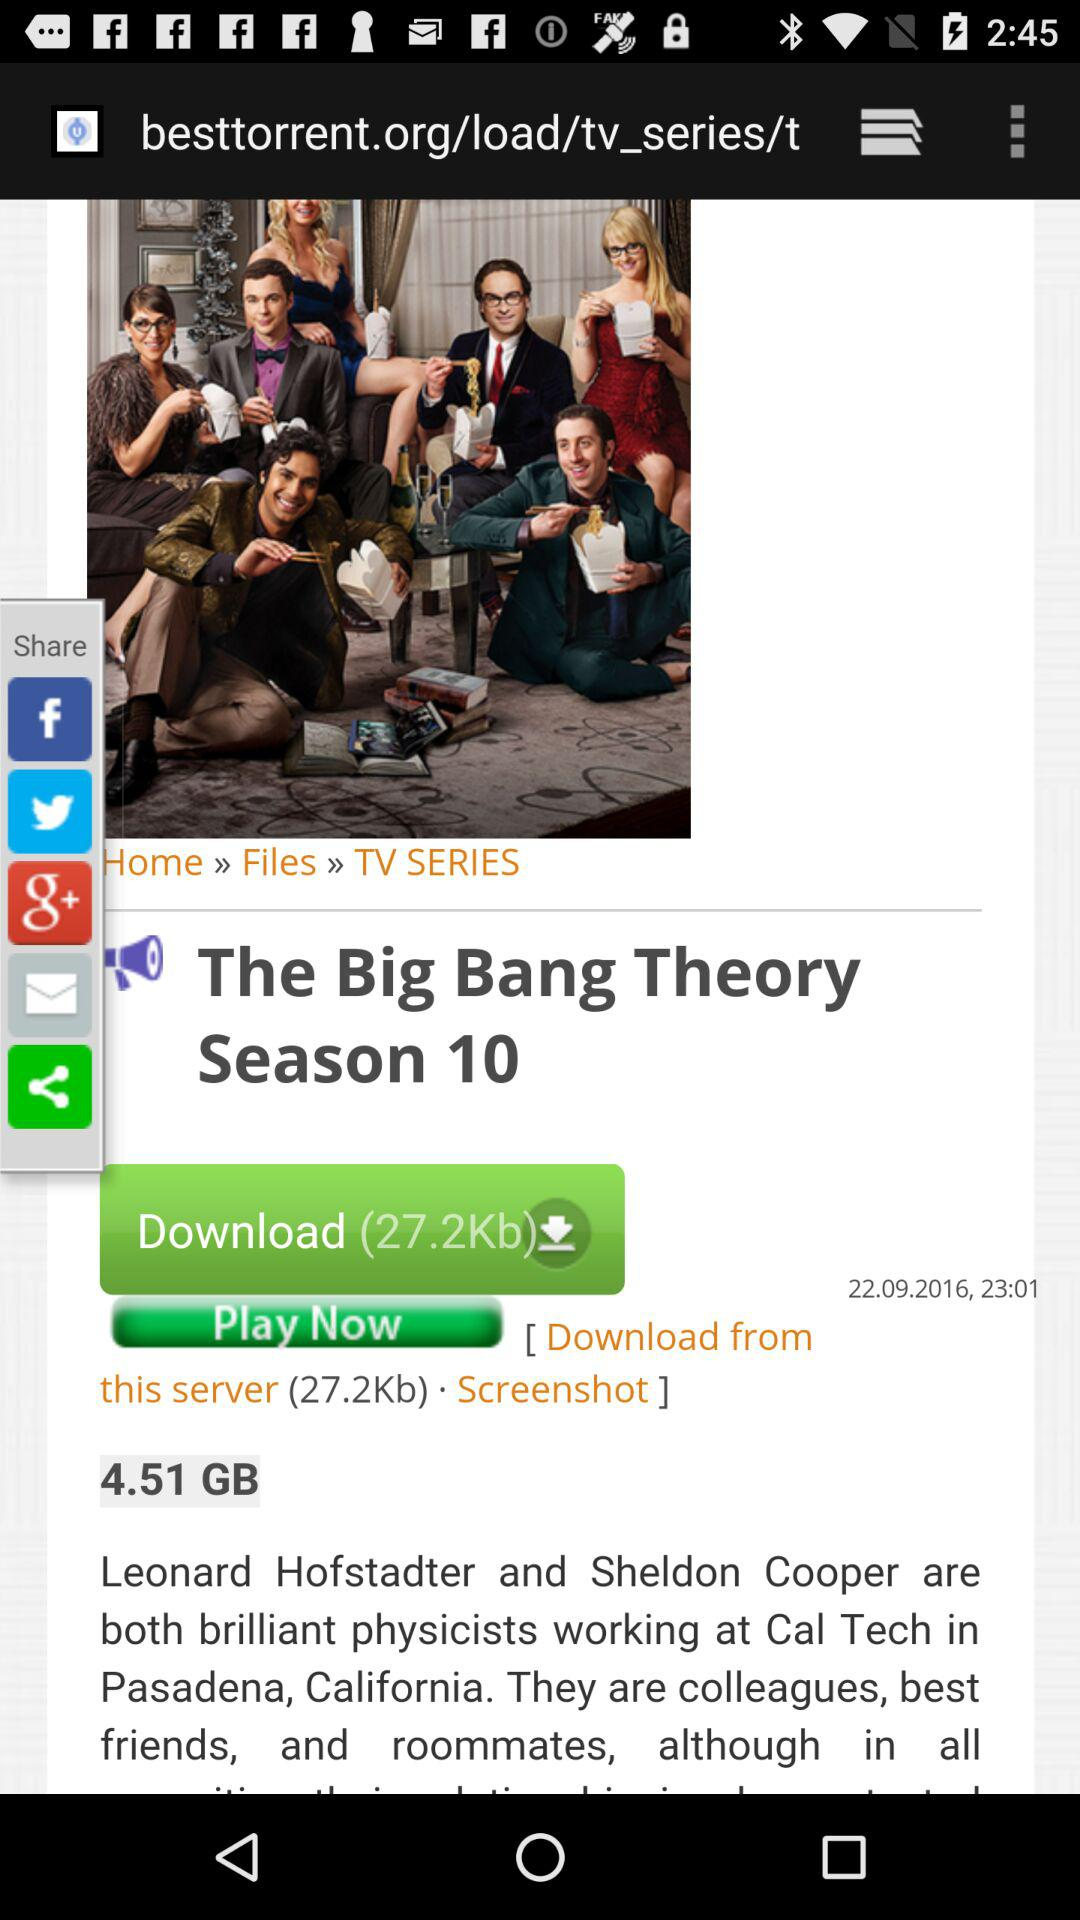How many KB will be used in the download? The download will use 27.2 KB. 